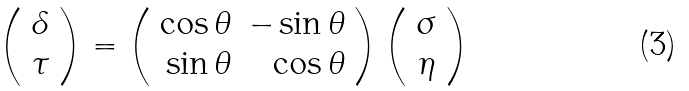<formula> <loc_0><loc_0><loc_500><loc_500>\left ( \begin{array} { c } \delta \\ \tau \end{array} \right ) = \left ( \begin{array} { r r } \cos \theta & - \sin \theta \\ \sin \theta & \cos \theta \end{array} \right ) \left ( \begin{array} { c } \sigma \\ \eta \end{array} \right )</formula> 